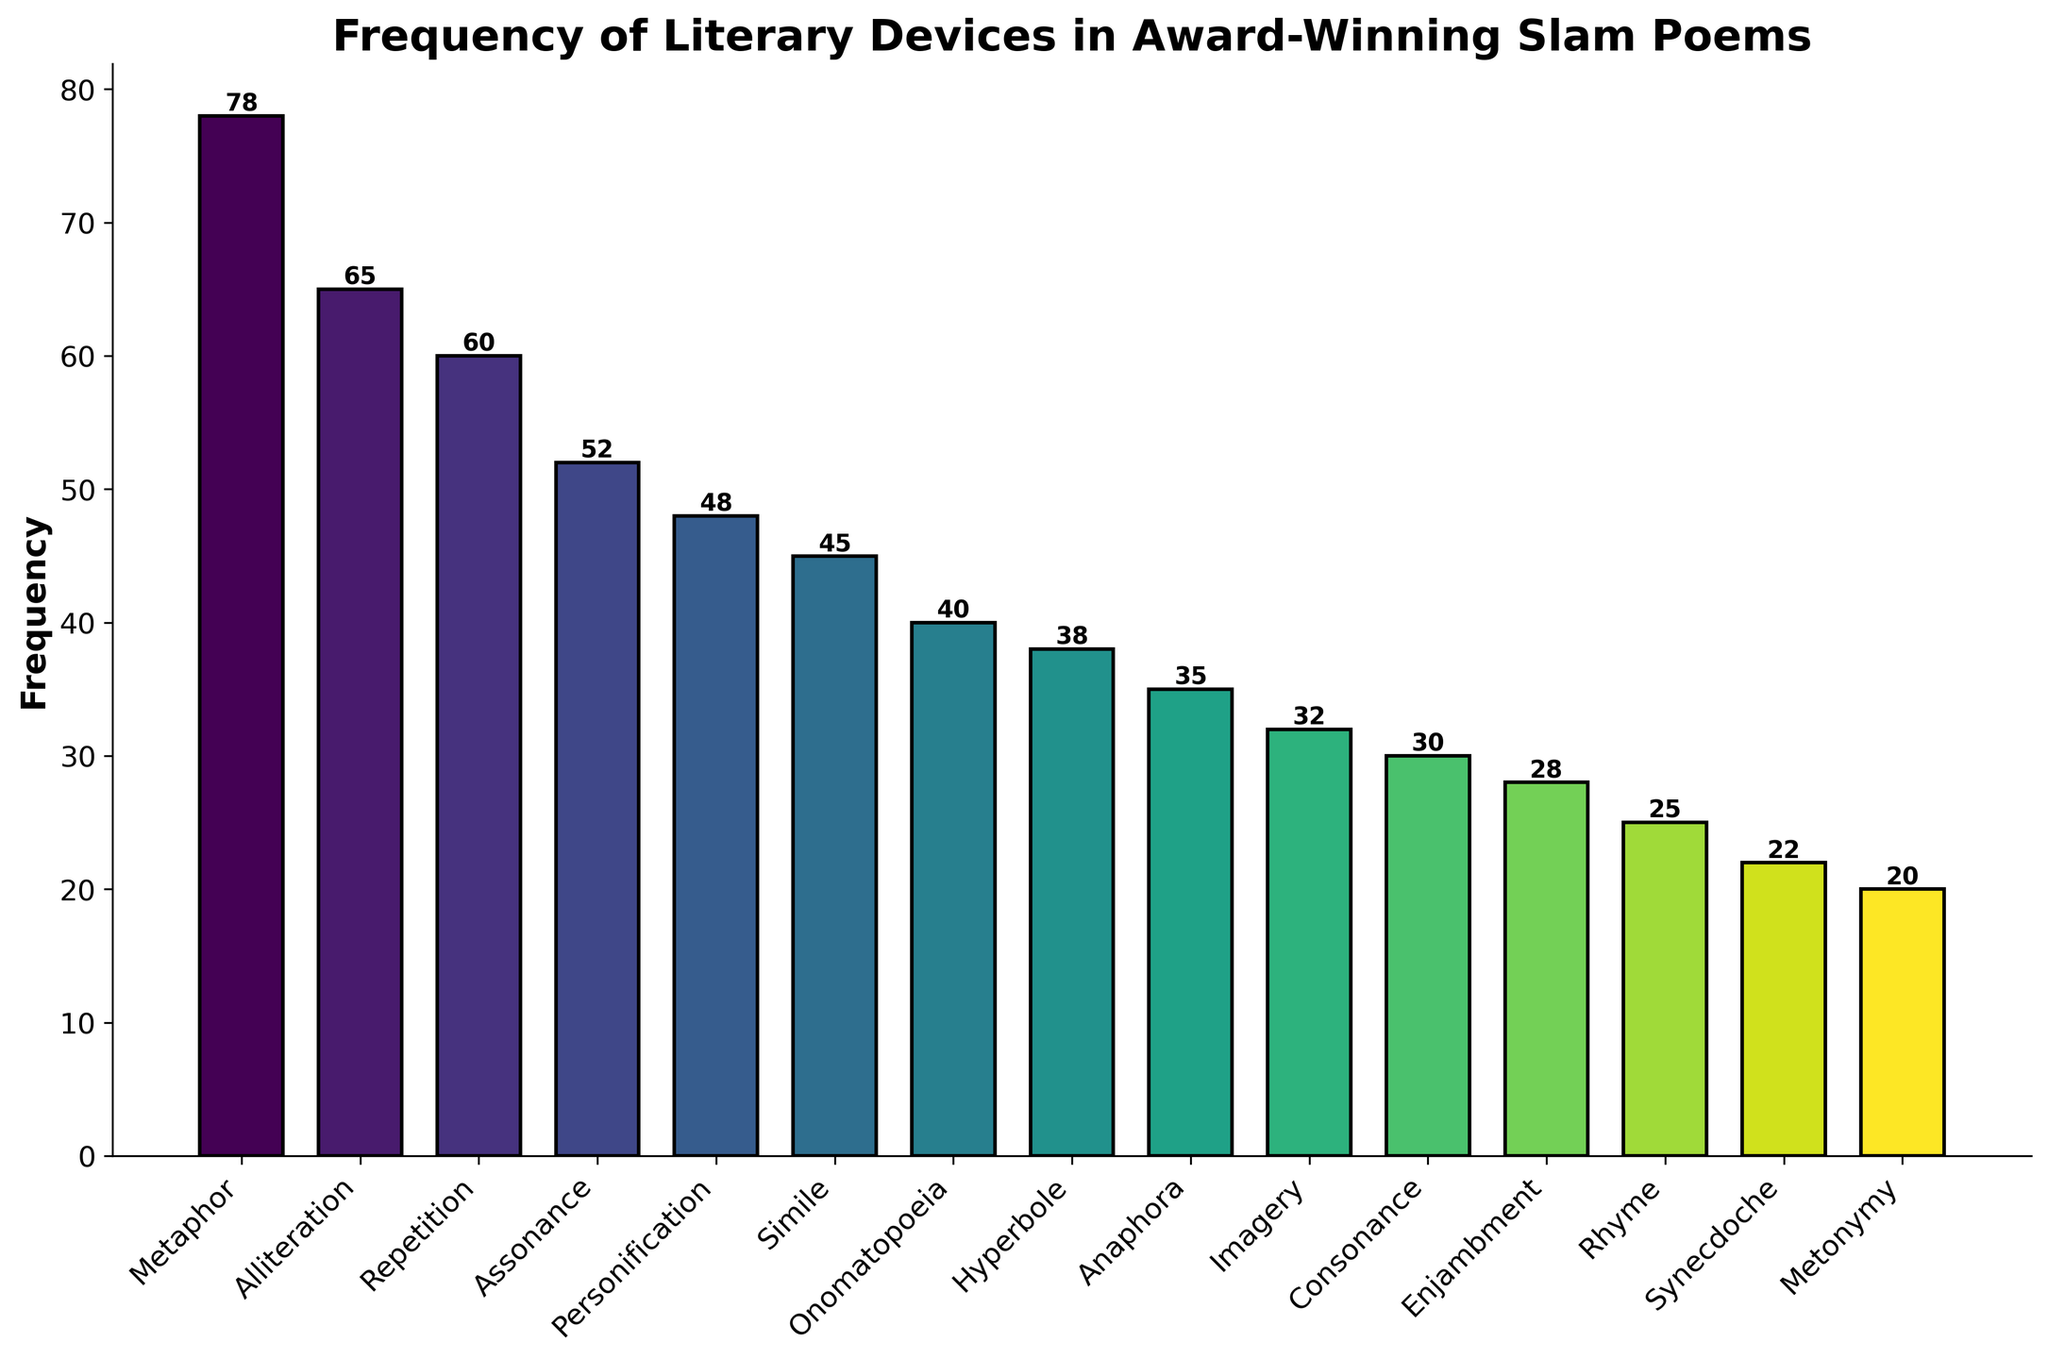What literary device is used most frequently? To determine the most frequently used device, look at the bar reaching the highest point. Metaphor is at the top, with a frequency of 78.
Answer: Metaphor What is the combined frequency of Alliteration and Repetition? Add the frequencies of Alliteration (65) and Repetition (60). The summation is 65 + 60 = 125.
Answer: 125 Which literary device is used more frequently: Assonance or Onomatopoeia? Compare the heights of the bars for Assonance (52) and Onomatopoeia (40). Assonance is higher, indicating greater frequency.
Answer: Assonance What is the difference in frequency between Personification and Simile? Subtract the frequency of Simile (45) from Personification (48). The difference is 48 - 45 = 3.
Answer: 3 Identify the least used literary device in the chart. The shortest bar signifies the least used device. Metonymy is at the bottom with a frequency of 20.
Answer: Metonymy Is the frequency of Anaphora greater than or equal to 35? Check the label on the bar for Anaphora, which is exactly 35.
Answer: Yes How many devices have a frequency above 50? Count the bars with frequencies higher than 50: Metaphor (78), Alliteration (65), Repetition (60), and Assonance (52). That's four devices.
Answer: 4 What is the frequency range (difference between the highest and lowest frequency) of the literary devices? Subtract the frequency of the least used device (Metonymy, 20) from the most used device (Metaphor, 78). The range is 78 - 20 = 58.
Answer: 58 Which devices fall below a frequency of 30? Identify bars with labels under 30: Consonance (30), Enjambment (28), Rhyme (25), Synecdoche (22), and Metonymy (20).
Answer: Consonance, Enjambment, Rhyme, Synecdoche, Metonymy 